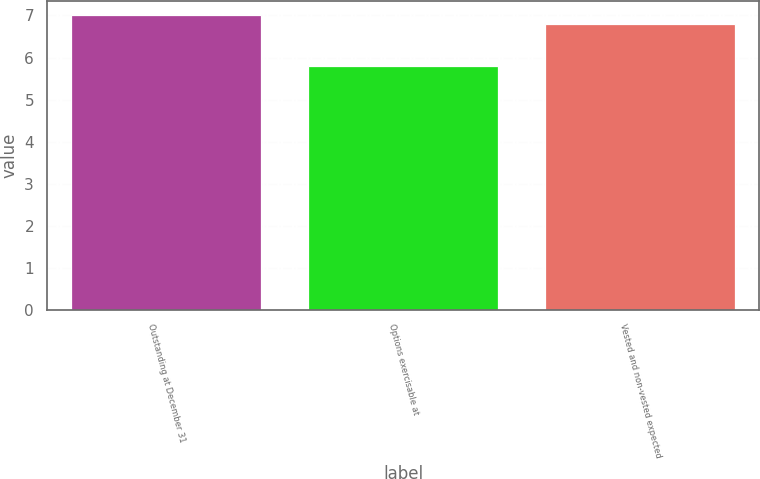Convert chart. <chart><loc_0><loc_0><loc_500><loc_500><bar_chart><fcel>Outstanding at December 31<fcel>Options exercisable at<fcel>Vested and non-vested expected<nl><fcel>7<fcel>5.8<fcel>6.8<nl></chart> 